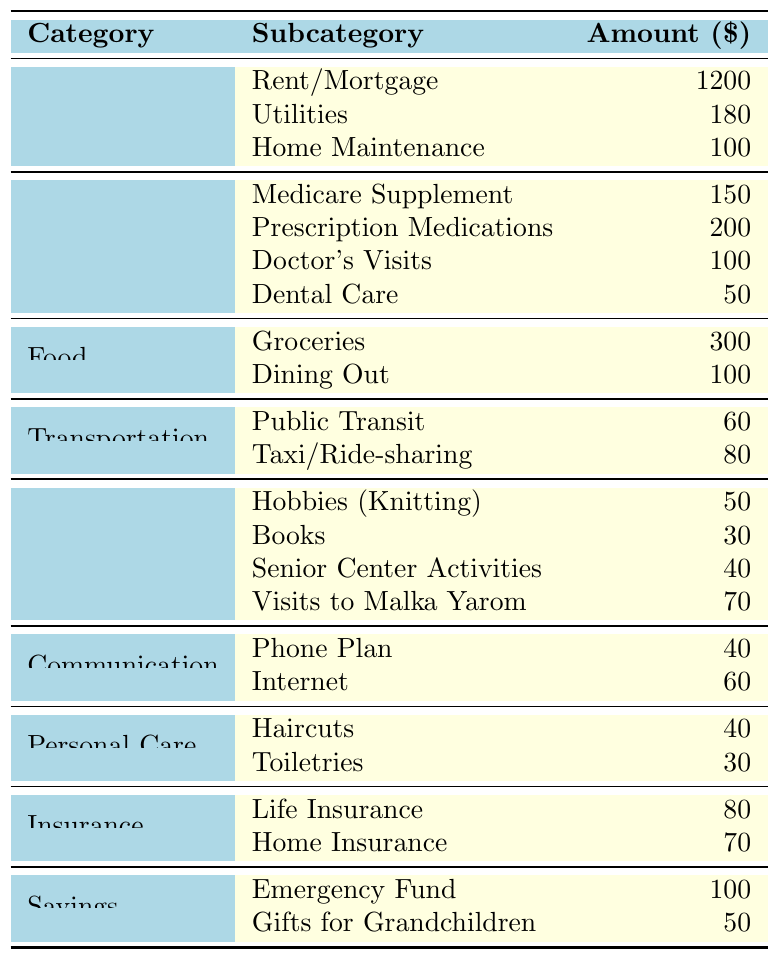What is the total amount allocated for healthcare expenses? To find the total amount allocated for healthcare, we add all the healthcare subcategories: Medicare Supplement (150) + Prescription Medications (200) + Doctor's Visits (100) + Dental Care (50) = 500.
Answer: 500 What is the amount spent on leisure activities overall? The total for leisure is calculated by summing the leisure subcategories: Hobbies (Knitting) (50) + Books (30) + Senior Center Activities (40) + Visits to Malka Yarom (70) = 190.
Answer: 190 Is the amount spent on groceries more than the amount spent on dental care? Groceries amount to 300 and dental care amounts to 50. Since 300 is greater than 50, the statement is true.
Answer: Yes How much is spent on personal care in total? The total personal care expenses are found by adding the subcategories: Haircuts (40) + Toiletries (30) = 70.
Answer: 70 Which category has the highest individual expense, and what is that amount? Housing has the highest individual expense for Rent/Mortgage at 1200, which is more than any other individual item in any category.
Answer: Housing (1200) What is the total amount spent on communication and transportation combined? To find the combined total for communication and transportation, we sum their expenses: Communication (Phone Plan (40) + Internet (60) = 100) and Transportation (Public Transit (60) + Taxi/Ride-sharing (80) = 140). Thus, 100 + 140 = 240.
Answer: 240 If I wanted to set aside 5% of my total budget for emergencies, what would that amount be? First, calculate the total budget by summing all amounts in the table: 1200 + 180 + 100 + 500 + 400 + 140 + 70 + 150 + 150 = 3080. Then calculate 5% of 3080, which is 3080 * 0.05 = 154.
Answer: 154 How much more is spent on rent/mortgage compared to the total spent on the phone and internet plans? Rent/Mortgage is 1200 and the total for phone and internet is Phone Plan (40) + Internet (60) = 100. The difference is 1200 - 100 = 1100.
Answer: 1100 What is the average amount spent on food? To find the average, sum the food expenses: Groceries (300) + Dining Out (100) = 400. There are 2 subcategories, so 400 ÷ 2 = 200.
Answer: 200 How much is spent on gifts for grandchildren compared to home maintenance expenses? Gifts for Grandchildren amount to 50 and Home Maintenance is 100. Since 50 is less than 100, the statement is true.
Answer: No 